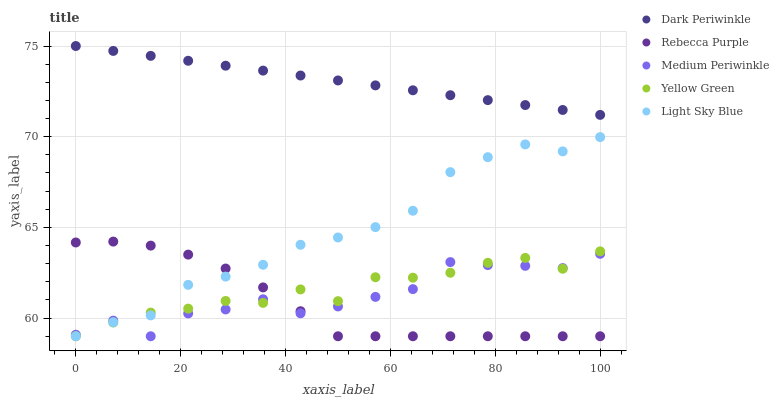Does Rebecca Purple have the minimum area under the curve?
Answer yes or no. Yes. Does Dark Periwinkle have the maximum area under the curve?
Answer yes or no. Yes. Does Light Sky Blue have the minimum area under the curve?
Answer yes or no. No. Does Light Sky Blue have the maximum area under the curve?
Answer yes or no. No. Is Dark Periwinkle the smoothest?
Answer yes or no. Yes. Is Medium Periwinkle the roughest?
Answer yes or no. Yes. Is Light Sky Blue the smoothest?
Answer yes or no. No. Is Light Sky Blue the roughest?
Answer yes or no. No. Does Yellow Green have the lowest value?
Answer yes or no. Yes. Does Dark Periwinkle have the lowest value?
Answer yes or no. No. Does Dark Periwinkle have the highest value?
Answer yes or no. Yes. Does Light Sky Blue have the highest value?
Answer yes or no. No. Is Light Sky Blue less than Dark Periwinkle?
Answer yes or no. Yes. Is Dark Periwinkle greater than Medium Periwinkle?
Answer yes or no. Yes. Does Light Sky Blue intersect Medium Periwinkle?
Answer yes or no. Yes. Is Light Sky Blue less than Medium Periwinkle?
Answer yes or no. No. Is Light Sky Blue greater than Medium Periwinkle?
Answer yes or no. No. Does Light Sky Blue intersect Dark Periwinkle?
Answer yes or no. No. 